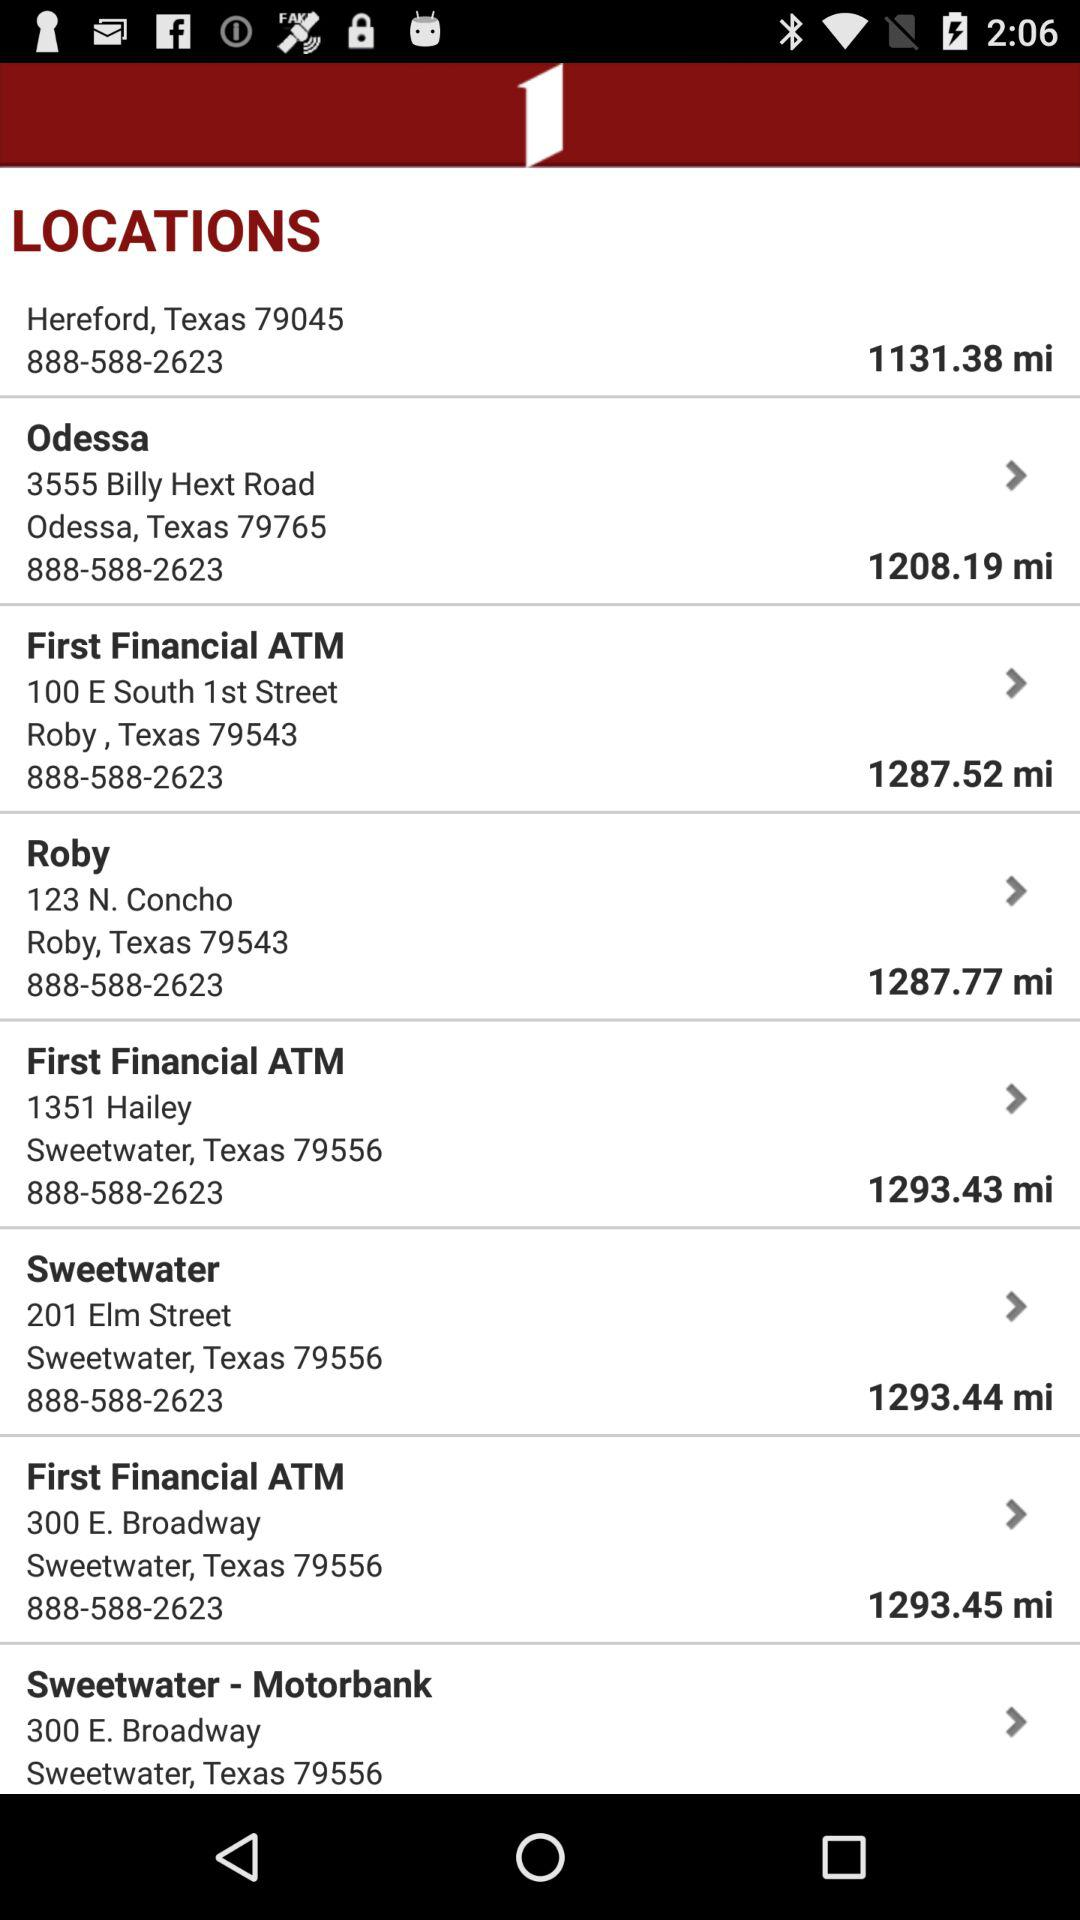What is the location of Roby given? The location is 123 N. Concho Roby, Texas 79543. 